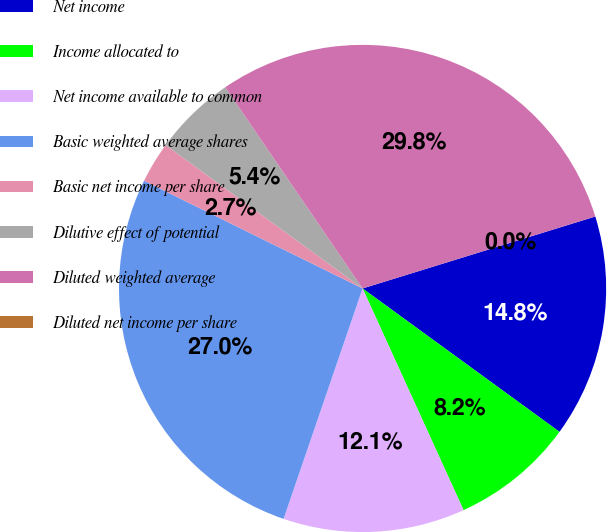<chart> <loc_0><loc_0><loc_500><loc_500><pie_chart><fcel>Net income<fcel>Income allocated to<fcel>Net income available to common<fcel>Basic weighted average shares<fcel>Basic net income per share<fcel>Dilutive effect of potential<fcel>Diluted weighted average<fcel>Diluted net income per share<nl><fcel>14.79%<fcel>8.18%<fcel>12.06%<fcel>27.03%<fcel>2.73%<fcel>5.45%<fcel>29.76%<fcel>0.0%<nl></chart> 